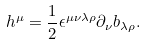Convert formula to latex. <formula><loc_0><loc_0><loc_500><loc_500>h ^ { \mu } = \frac { 1 } { 2 } \epsilon ^ { \mu \nu \lambda \rho } \partial _ { \nu } b _ { \lambda \rho } .</formula> 